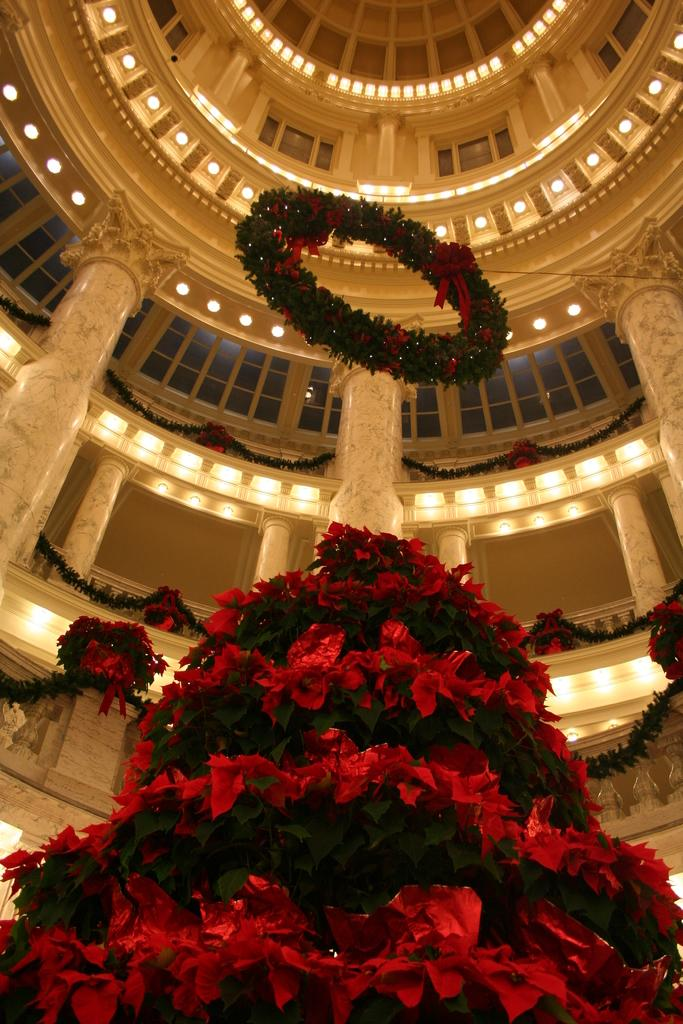What type of plants can be seen in the image? There are flowers and leaves in the image. What structure is present in the image? There is a wreath in the image. What architectural features can be seen in the image? There are pillars in the image. What lighting elements are visible in the image? There are lights in the image. What type of openings can be seen in the image? There are windows in the image. What type of power source is used to operate the lights in the image? There is no information about the power source for the lights in the image. Are there any slaves depicted in the image? There is no mention of slaves or any human figures in the image. 